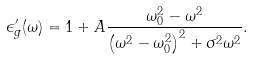<formula> <loc_0><loc_0><loc_500><loc_500>\epsilon _ { g } ^ { \prime } ( \omega ) = 1 + A \frac { \omega _ { 0 } ^ { 2 } - \omega ^ { 2 } } { \left ( \omega ^ { 2 } - \omega _ { 0 } ^ { 2 } \right ) ^ { 2 } + \sigma ^ { 2 } \omega ^ { 2 } } .</formula> 